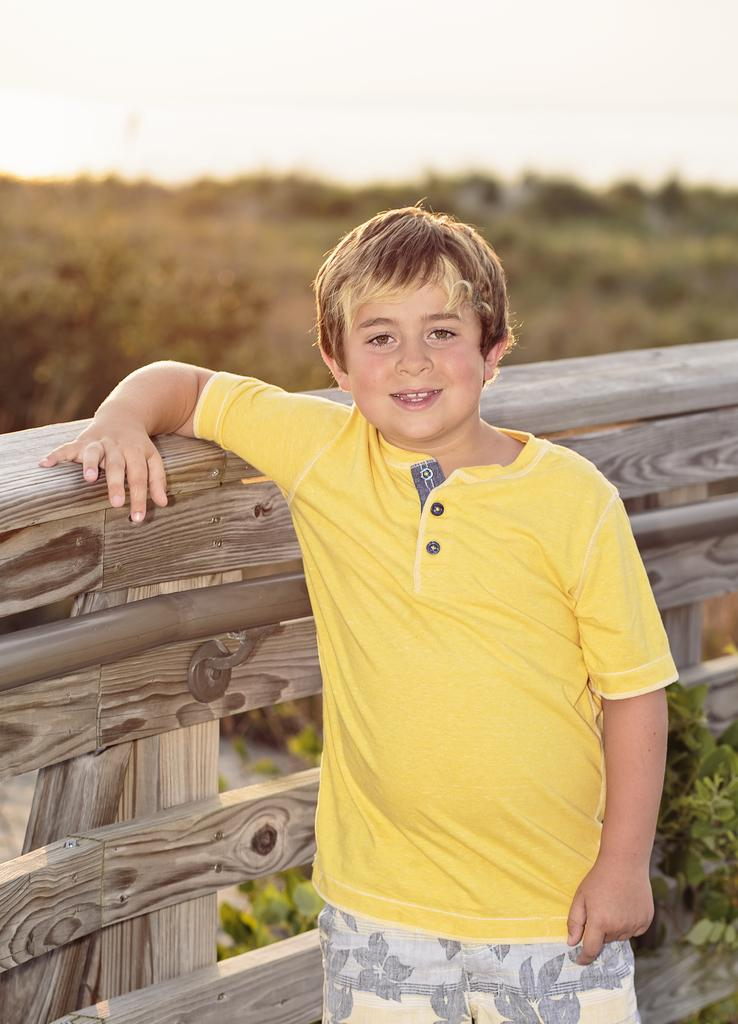Who is the main subject in the image? There is a boy in the middle of the image. What is the boy doing in the image? The boy has his hand on a wooden fence. What can be seen beside the boy? There are plants beside the boy. What is visible in the background of the image? There are plants visible in the background of the image. What type of glue is the boy using to stick the plants together in the image? There is no glue or indication of sticking plants together in the image. 